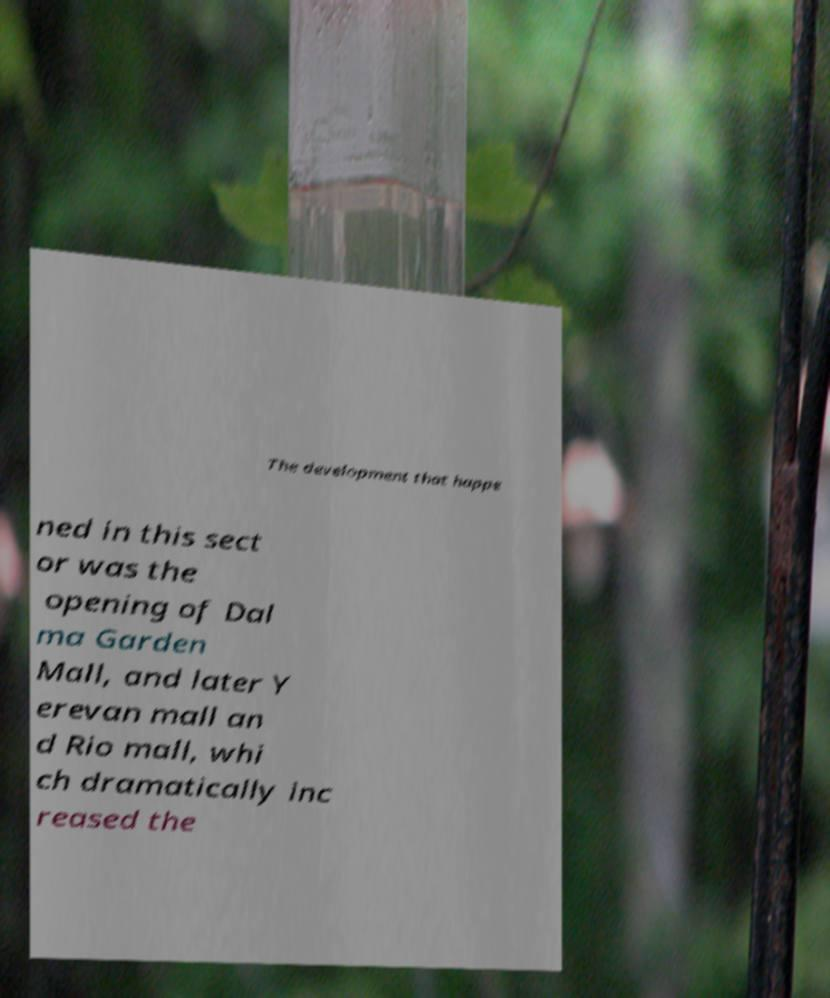Could you assist in decoding the text presented in this image and type it out clearly? The development that happe ned in this sect or was the opening of Dal ma Garden Mall, and later Y erevan mall an d Rio mall, whi ch dramatically inc reased the 